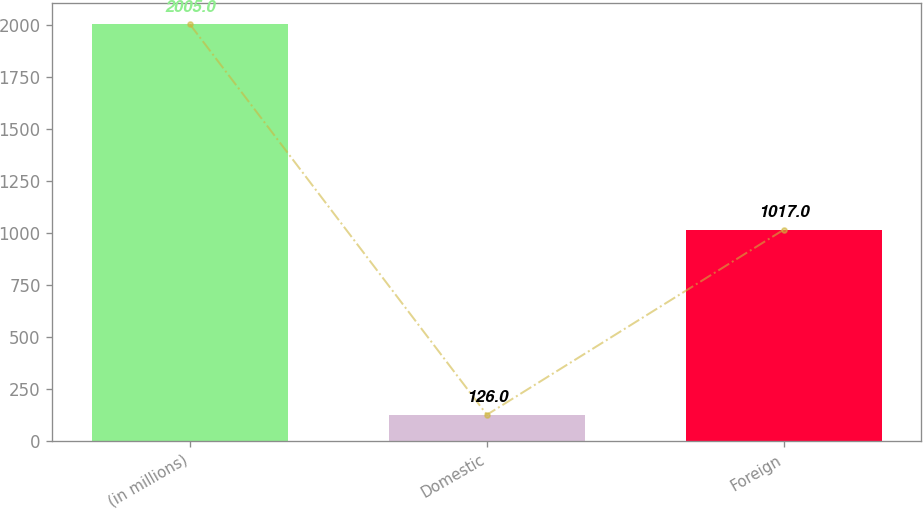<chart> <loc_0><loc_0><loc_500><loc_500><bar_chart><fcel>(in millions)<fcel>Domestic<fcel>Foreign<nl><fcel>2005<fcel>126<fcel>1017<nl></chart> 